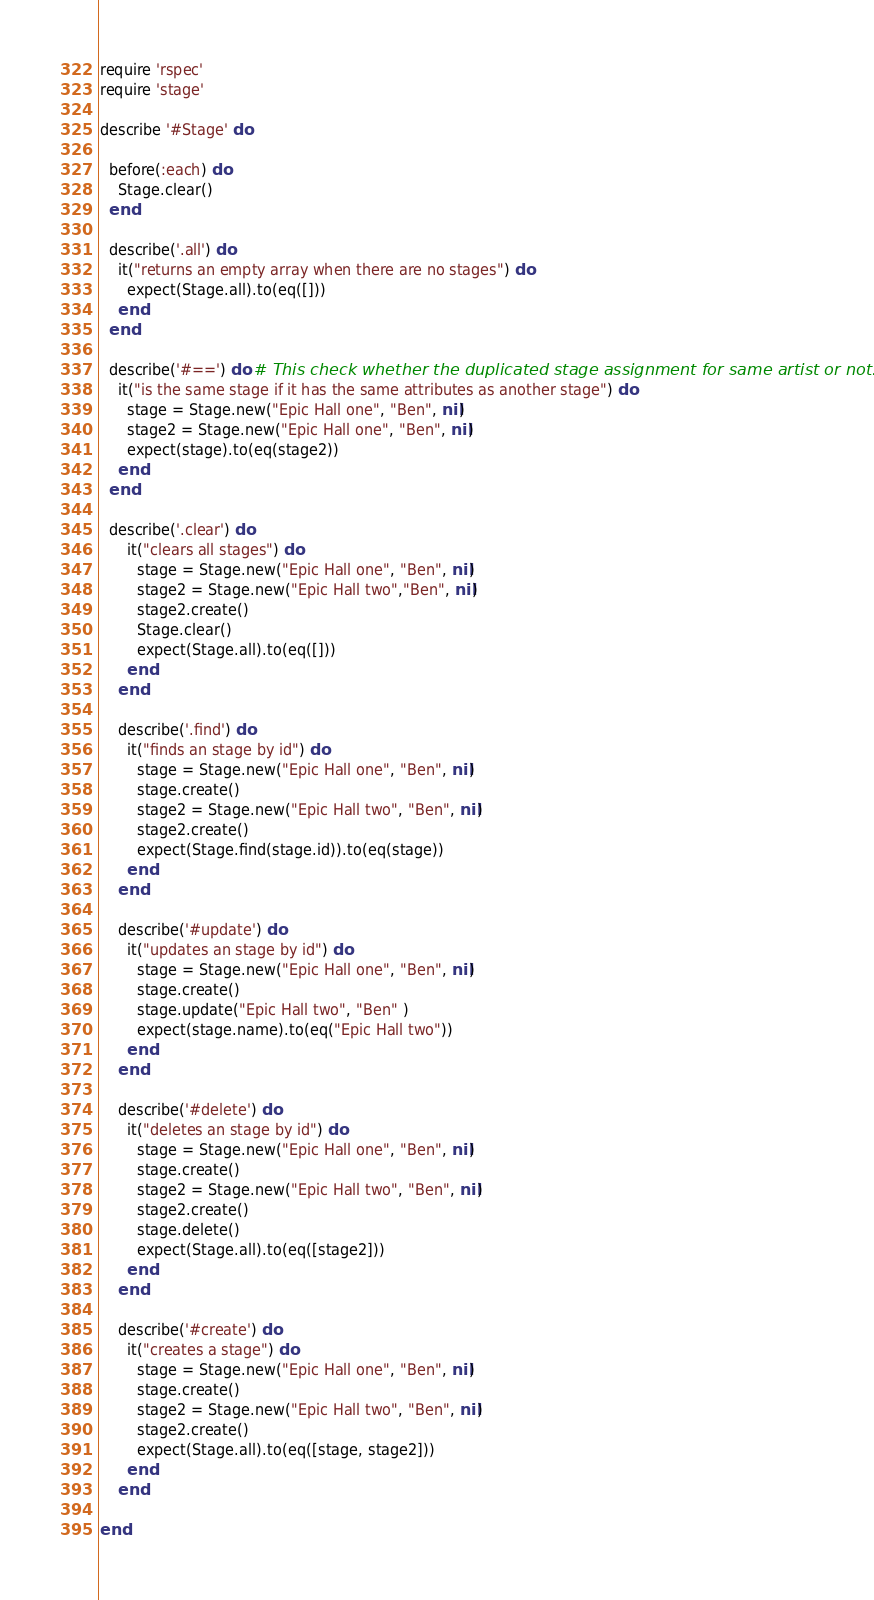Convert code to text. <code><loc_0><loc_0><loc_500><loc_500><_Ruby_>require 'rspec'
require 'stage'

describe '#Stage' do

  before(:each) do
    Stage.clear()
  end

  describe('.all') do
    it("returns an empty array when there are no stages") do
      expect(Stage.all).to(eq([]))
    end
  end

  describe('#==') do # This check whether the duplicated stage assignment for same artist or not.
    it("is the same stage if it has the same attributes as another stage") do
      stage = Stage.new("Epic Hall one", "Ben", nil)
      stage2 = Stage.new("Epic Hall one", "Ben", nil)
      expect(stage).to(eq(stage2))
    end
  end

  describe('.clear') do
      it("clears all stages") do
        stage = Stage.new("Epic Hall one", "Ben", nil)
        stage2 = Stage.new("Epic Hall two","Ben", nil)
        stage2.create()
        Stage.clear()
        expect(Stage.all).to(eq([]))
      end
    end

    describe('.find') do
      it("finds an stage by id") do
        stage = Stage.new("Epic Hall one", "Ben", nil)
        stage.create()
        stage2 = Stage.new("Epic Hall two", "Ben", nil)
        stage2.create()
        expect(Stage.find(stage.id)).to(eq(stage))
      end
    end

    describe('#update') do
      it("updates an stage by id") do
        stage = Stage.new("Epic Hall one", "Ben", nil)
        stage.create()
        stage.update("Epic Hall two", "Ben" )
        expect(stage.name).to(eq("Epic Hall two"))
      end
    end

    describe('#delete') do
      it("deletes an stage by id") do
        stage = Stage.new("Epic Hall one", "Ben", nil)
        stage.create()
        stage2 = Stage.new("Epic Hall two", "Ben", nil)
        stage2.create()
        stage.delete()
        expect(Stage.all).to(eq([stage2]))
      end
    end

    describe('#create') do
      it("creates a stage") do
        stage = Stage.new("Epic Hall one", "Ben", nil)
        stage.create()
        stage2 = Stage.new("Epic Hall two", "Ben", nil)
        stage2.create()
        expect(Stage.all).to(eq([stage, stage2]))
      end
    end
    
end
</code> 